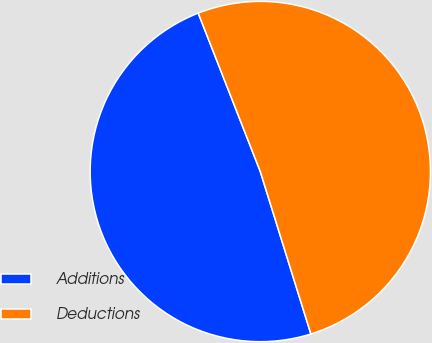<chart> <loc_0><loc_0><loc_500><loc_500><pie_chart><fcel>Additions<fcel>Deductions<nl><fcel>48.86%<fcel>51.14%<nl></chart> 